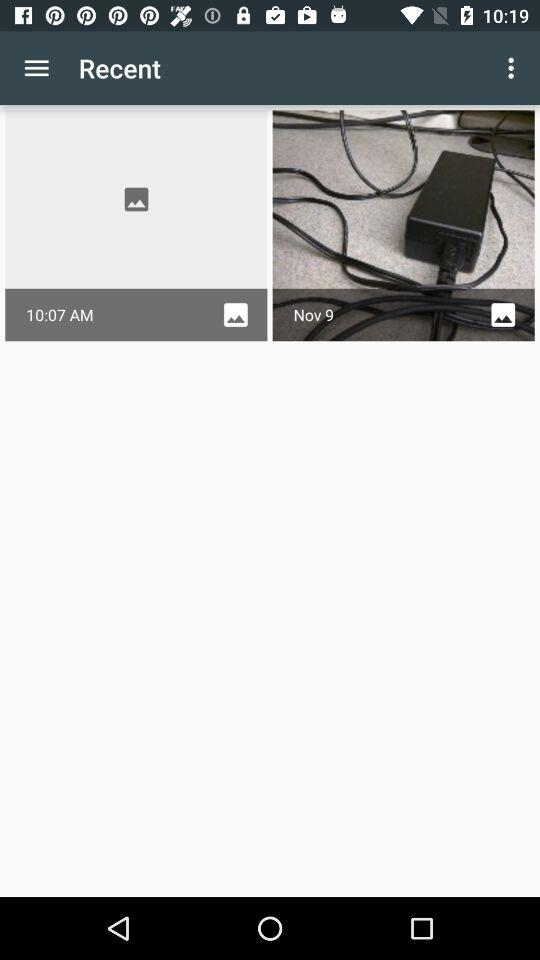What is the date shown on the screen? The date shown on the screen is November 9. 